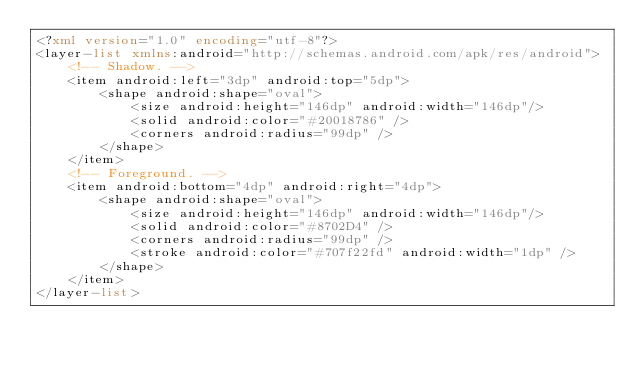<code> <loc_0><loc_0><loc_500><loc_500><_XML_><?xml version="1.0" encoding="utf-8"?>
<layer-list xmlns:android="http://schemas.android.com/apk/res/android">
    <!-- Shadow. -->
    <item android:left="3dp" android:top="5dp">
        <shape android:shape="oval">
            <size android:height="146dp" android:width="146dp"/>
            <solid android:color="#20018786" />
            <corners android:radius="99dp" />
        </shape>
    </item>
    <!-- Foreground. -->
    <item android:bottom="4dp" android:right="4dp">
        <shape android:shape="oval">
            <size android:height="146dp" android:width="146dp"/>
            <solid android:color="#8702D4" />
            <corners android:radius="99dp" />
            <stroke android:color="#707f22fd" android:width="1dp" />
        </shape>
    </item>
</layer-list></code> 